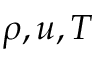Convert formula to latex. <formula><loc_0><loc_0><loc_500><loc_500>\rho , u , T</formula> 